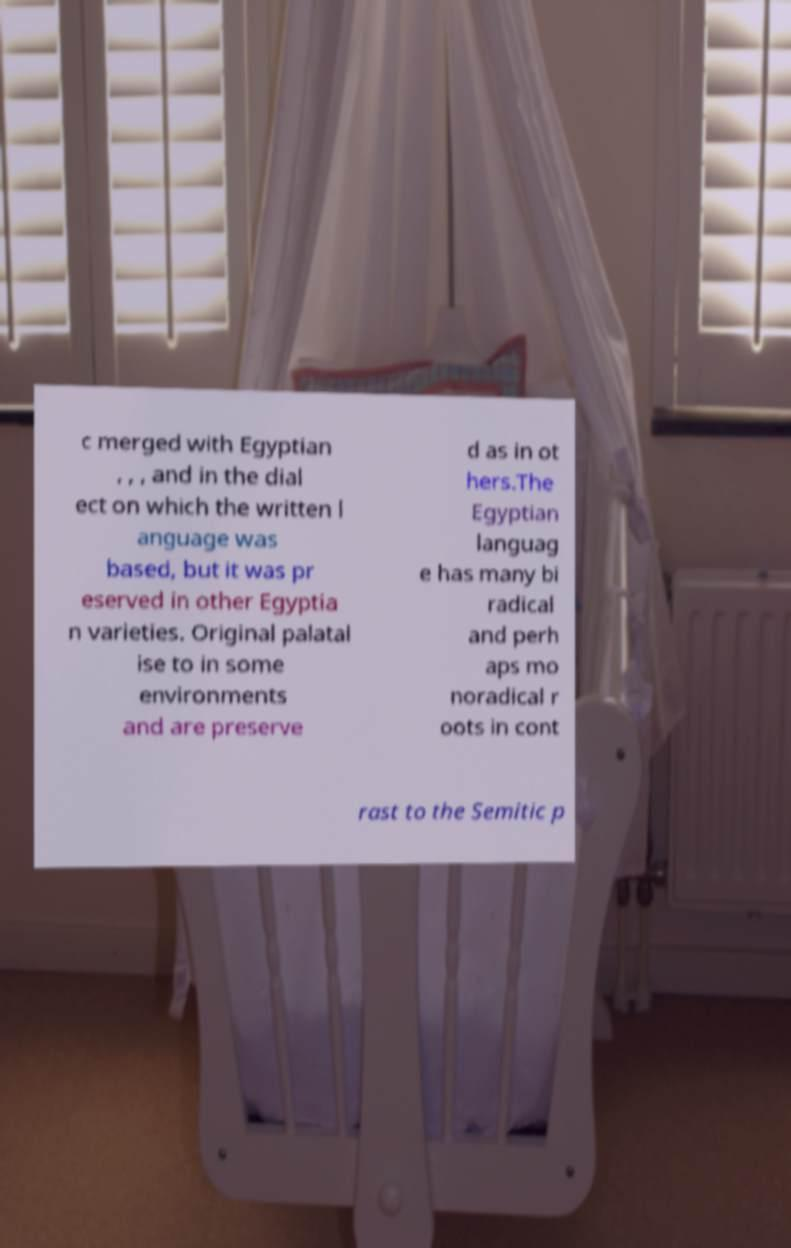There's text embedded in this image that I need extracted. Can you transcribe it verbatim? c merged with Egyptian , , , and in the dial ect on which the written l anguage was based, but it was pr eserved in other Egyptia n varieties. Original palatal ise to in some environments and are preserve d as in ot hers.The Egyptian languag e has many bi radical and perh aps mo noradical r oots in cont rast to the Semitic p 